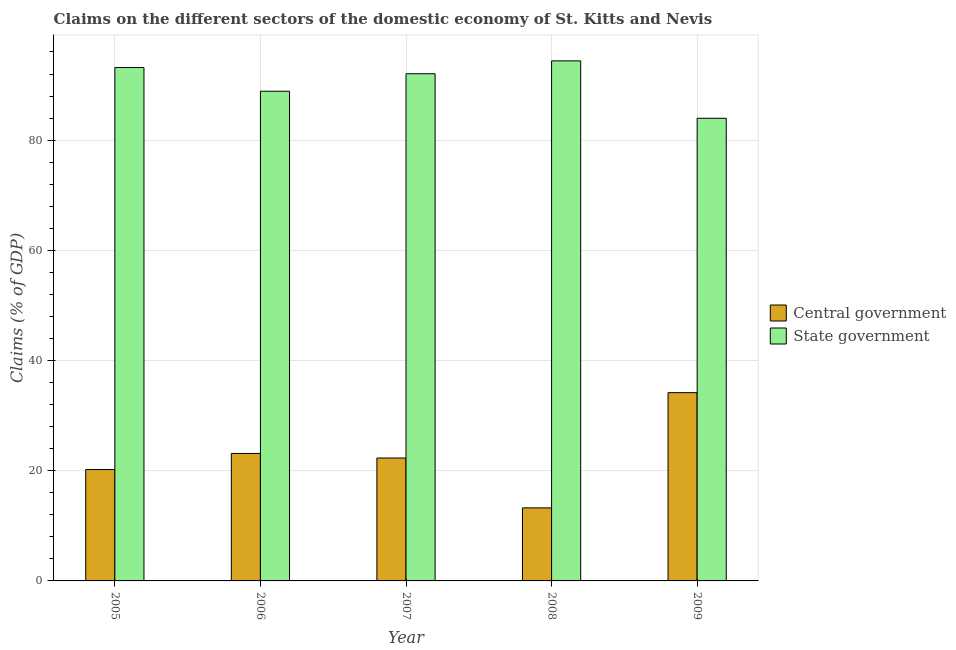How many groups of bars are there?
Provide a short and direct response. 5. Are the number of bars on each tick of the X-axis equal?
Your answer should be compact. Yes. How many bars are there on the 5th tick from the left?
Offer a very short reply. 2. In how many cases, is the number of bars for a given year not equal to the number of legend labels?
Provide a short and direct response. 0. What is the claims on state government in 2006?
Provide a succinct answer. 88.87. Across all years, what is the maximum claims on state government?
Ensure brevity in your answer.  94.38. Across all years, what is the minimum claims on central government?
Your answer should be compact. 13.26. In which year was the claims on central government maximum?
Your answer should be compact. 2009. In which year was the claims on state government minimum?
Provide a short and direct response. 2009. What is the total claims on state government in the graph?
Your response must be concise. 452.44. What is the difference between the claims on central government in 2007 and that in 2008?
Make the answer very short. 9.05. What is the difference between the claims on state government in 2008 and the claims on central government in 2007?
Provide a succinct answer. 2.33. What is the average claims on state government per year?
Give a very brief answer. 90.49. In the year 2005, what is the difference between the claims on state government and claims on central government?
Provide a short and direct response. 0. In how many years, is the claims on central government greater than 72 %?
Make the answer very short. 0. What is the ratio of the claims on central government in 2007 to that in 2008?
Give a very brief answer. 1.68. Is the claims on central government in 2007 less than that in 2009?
Ensure brevity in your answer.  Yes. What is the difference between the highest and the second highest claims on central government?
Offer a very short reply. 11.03. What is the difference between the highest and the lowest claims on central government?
Provide a succinct answer. 20.91. In how many years, is the claims on state government greater than the average claims on state government taken over all years?
Ensure brevity in your answer.  3. What does the 2nd bar from the left in 2007 represents?
Keep it short and to the point. State government. What does the 1st bar from the right in 2008 represents?
Provide a succinct answer. State government. How many bars are there?
Your answer should be very brief. 10. Are all the bars in the graph horizontal?
Your response must be concise. No. Are the values on the major ticks of Y-axis written in scientific E-notation?
Provide a succinct answer. No. Where does the legend appear in the graph?
Keep it short and to the point. Center right. How many legend labels are there?
Your answer should be very brief. 2. What is the title of the graph?
Offer a very short reply. Claims on the different sectors of the domestic economy of St. Kitts and Nevis. Does "Boys" appear as one of the legend labels in the graph?
Make the answer very short. No. What is the label or title of the Y-axis?
Your answer should be compact. Claims (% of GDP). What is the Claims (% of GDP) in Central government in 2005?
Keep it short and to the point. 20.22. What is the Claims (% of GDP) in State government in 2005?
Give a very brief answer. 93.17. What is the Claims (% of GDP) in Central government in 2006?
Keep it short and to the point. 23.14. What is the Claims (% of GDP) in State government in 2006?
Provide a succinct answer. 88.87. What is the Claims (% of GDP) in Central government in 2007?
Your answer should be very brief. 22.31. What is the Claims (% of GDP) in State government in 2007?
Your answer should be very brief. 92.05. What is the Claims (% of GDP) of Central government in 2008?
Make the answer very short. 13.26. What is the Claims (% of GDP) of State government in 2008?
Provide a succinct answer. 94.38. What is the Claims (% of GDP) of Central government in 2009?
Keep it short and to the point. 34.17. What is the Claims (% of GDP) in State government in 2009?
Ensure brevity in your answer.  83.97. Across all years, what is the maximum Claims (% of GDP) of Central government?
Provide a short and direct response. 34.17. Across all years, what is the maximum Claims (% of GDP) in State government?
Your response must be concise. 94.38. Across all years, what is the minimum Claims (% of GDP) of Central government?
Offer a very short reply. 13.26. Across all years, what is the minimum Claims (% of GDP) of State government?
Give a very brief answer. 83.97. What is the total Claims (% of GDP) in Central government in the graph?
Offer a terse response. 113.09. What is the total Claims (% of GDP) of State government in the graph?
Offer a terse response. 452.44. What is the difference between the Claims (% of GDP) of Central government in 2005 and that in 2006?
Keep it short and to the point. -2.92. What is the difference between the Claims (% of GDP) of State government in 2005 and that in 2006?
Offer a terse response. 4.3. What is the difference between the Claims (% of GDP) of Central government in 2005 and that in 2007?
Offer a very short reply. -2.09. What is the difference between the Claims (% of GDP) in State government in 2005 and that in 2007?
Give a very brief answer. 1.13. What is the difference between the Claims (% of GDP) of Central government in 2005 and that in 2008?
Your answer should be very brief. 6.96. What is the difference between the Claims (% of GDP) in State government in 2005 and that in 2008?
Your response must be concise. -1.21. What is the difference between the Claims (% of GDP) of Central government in 2005 and that in 2009?
Give a very brief answer. -13.95. What is the difference between the Claims (% of GDP) in State government in 2005 and that in 2009?
Keep it short and to the point. 9.21. What is the difference between the Claims (% of GDP) of Central government in 2006 and that in 2007?
Ensure brevity in your answer.  0.83. What is the difference between the Claims (% of GDP) of State government in 2006 and that in 2007?
Your response must be concise. -3.17. What is the difference between the Claims (% of GDP) of Central government in 2006 and that in 2008?
Ensure brevity in your answer.  9.88. What is the difference between the Claims (% of GDP) of State government in 2006 and that in 2008?
Ensure brevity in your answer.  -5.51. What is the difference between the Claims (% of GDP) of Central government in 2006 and that in 2009?
Offer a very short reply. -11.03. What is the difference between the Claims (% of GDP) in State government in 2006 and that in 2009?
Your answer should be very brief. 4.91. What is the difference between the Claims (% of GDP) in Central government in 2007 and that in 2008?
Ensure brevity in your answer.  9.05. What is the difference between the Claims (% of GDP) in State government in 2007 and that in 2008?
Your response must be concise. -2.33. What is the difference between the Claims (% of GDP) of Central government in 2007 and that in 2009?
Provide a short and direct response. -11.86. What is the difference between the Claims (% of GDP) in State government in 2007 and that in 2009?
Ensure brevity in your answer.  8.08. What is the difference between the Claims (% of GDP) of Central government in 2008 and that in 2009?
Your answer should be compact. -20.91. What is the difference between the Claims (% of GDP) of State government in 2008 and that in 2009?
Keep it short and to the point. 10.42. What is the difference between the Claims (% of GDP) of Central government in 2005 and the Claims (% of GDP) of State government in 2006?
Ensure brevity in your answer.  -68.65. What is the difference between the Claims (% of GDP) of Central government in 2005 and the Claims (% of GDP) of State government in 2007?
Offer a terse response. -71.83. What is the difference between the Claims (% of GDP) in Central government in 2005 and the Claims (% of GDP) in State government in 2008?
Provide a succinct answer. -74.16. What is the difference between the Claims (% of GDP) of Central government in 2005 and the Claims (% of GDP) of State government in 2009?
Offer a very short reply. -63.75. What is the difference between the Claims (% of GDP) in Central government in 2006 and the Claims (% of GDP) in State government in 2007?
Provide a succinct answer. -68.91. What is the difference between the Claims (% of GDP) in Central government in 2006 and the Claims (% of GDP) in State government in 2008?
Ensure brevity in your answer.  -71.24. What is the difference between the Claims (% of GDP) in Central government in 2006 and the Claims (% of GDP) in State government in 2009?
Ensure brevity in your answer.  -60.83. What is the difference between the Claims (% of GDP) of Central government in 2007 and the Claims (% of GDP) of State government in 2008?
Ensure brevity in your answer.  -72.07. What is the difference between the Claims (% of GDP) in Central government in 2007 and the Claims (% of GDP) in State government in 2009?
Provide a succinct answer. -61.66. What is the difference between the Claims (% of GDP) in Central government in 2008 and the Claims (% of GDP) in State government in 2009?
Offer a very short reply. -70.71. What is the average Claims (% of GDP) of Central government per year?
Offer a terse response. 22.62. What is the average Claims (% of GDP) in State government per year?
Offer a very short reply. 90.49. In the year 2005, what is the difference between the Claims (% of GDP) of Central government and Claims (% of GDP) of State government?
Offer a terse response. -72.95. In the year 2006, what is the difference between the Claims (% of GDP) in Central government and Claims (% of GDP) in State government?
Your answer should be compact. -65.73. In the year 2007, what is the difference between the Claims (% of GDP) of Central government and Claims (% of GDP) of State government?
Make the answer very short. -69.74. In the year 2008, what is the difference between the Claims (% of GDP) of Central government and Claims (% of GDP) of State government?
Provide a short and direct response. -81.13. In the year 2009, what is the difference between the Claims (% of GDP) of Central government and Claims (% of GDP) of State government?
Ensure brevity in your answer.  -49.8. What is the ratio of the Claims (% of GDP) in Central government in 2005 to that in 2006?
Provide a short and direct response. 0.87. What is the ratio of the Claims (% of GDP) in State government in 2005 to that in 2006?
Your response must be concise. 1.05. What is the ratio of the Claims (% of GDP) in Central government in 2005 to that in 2007?
Offer a very short reply. 0.91. What is the ratio of the Claims (% of GDP) of State government in 2005 to that in 2007?
Your response must be concise. 1.01. What is the ratio of the Claims (% of GDP) of Central government in 2005 to that in 2008?
Your response must be concise. 1.53. What is the ratio of the Claims (% of GDP) in State government in 2005 to that in 2008?
Provide a succinct answer. 0.99. What is the ratio of the Claims (% of GDP) of Central government in 2005 to that in 2009?
Your response must be concise. 0.59. What is the ratio of the Claims (% of GDP) of State government in 2005 to that in 2009?
Your response must be concise. 1.11. What is the ratio of the Claims (% of GDP) in Central government in 2006 to that in 2007?
Give a very brief answer. 1.04. What is the ratio of the Claims (% of GDP) in State government in 2006 to that in 2007?
Make the answer very short. 0.97. What is the ratio of the Claims (% of GDP) of Central government in 2006 to that in 2008?
Keep it short and to the point. 1.75. What is the ratio of the Claims (% of GDP) in State government in 2006 to that in 2008?
Give a very brief answer. 0.94. What is the ratio of the Claims (% of GDP) of Central government in 2006 to that in 2009?
Make the answer very short. 0.68. What is the ratio of the Claims (% of GDP) of State government in 2006 to that in 2009?
Provide a succinct answer. 1.06. What is the ratio of the Claims (% of GDP) of Central government in 2007 to that in 2008?
Your answer should be compact. 1.68. What is the ratio of the Claims (% of GDP) of State government in 2007 to that in 2008?
Offer a terse response. 0.98. What is the ratio of the Claims (% of GDP) in Central government in 2007 to that in 2009?
Your response must be concise. 0.65. What is the ratio of the Claims (% of GDP) in State government in 2007 to that in 2009?
Ensure brevity in your answer.  1.1. What is the ratio of the Claims (% of GDP) in Central government in 2008 to that in 2009?
Give a very brief answer. 0.39. What is the ratio of the Claims (% of GDP) in State government in 2008 to that in 2009?
Your answer should be compact. 1.12. What is the difference between the highest and the second highest Claims (% of GDP) in Central government?
Offer a very short reply. 11.03. What is the difference between the highest and the second highest Claims (% of GDP) of State government?
Provide a succinct answer. 1.21. What is the difference between the highest and the lowest Claims (% of GDP) in Central government?
Your answer should be compact. 20.91. What is the difference between the highest and the lowest Claims (% of GDP) of State government?
Your answer should be compact. 10.42. 